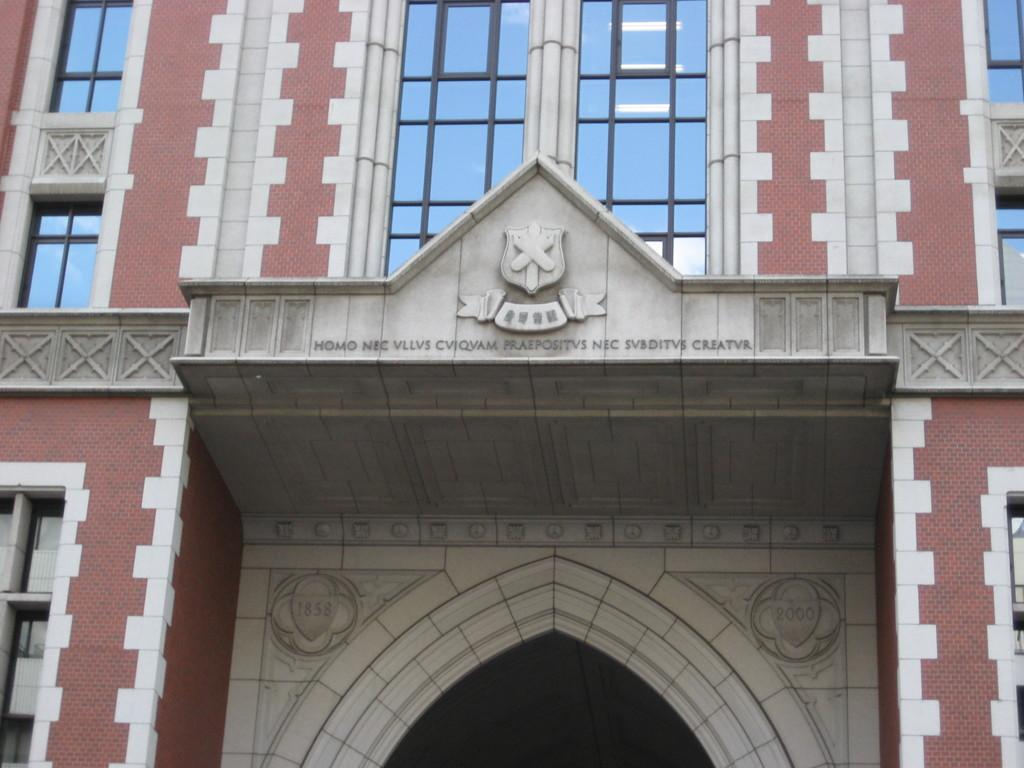What type of structure is visible in the image? There is a building in the image. What are some of the architectural features of the building? The building has walls, pillars, glass windows, arches, and walls with a logo. Can you describe the logo on the walls? There is something on the walls with a logo, but the specific design or details of the logo are not mentioned in the facts. Are there any numbers visible on the walls? Yes, there are numbers on the walls. Can you tell me how many buns are on the roof of the building in the image? There is no mention of buns in the image or the provided facts, so it is not possible to answer this question. 